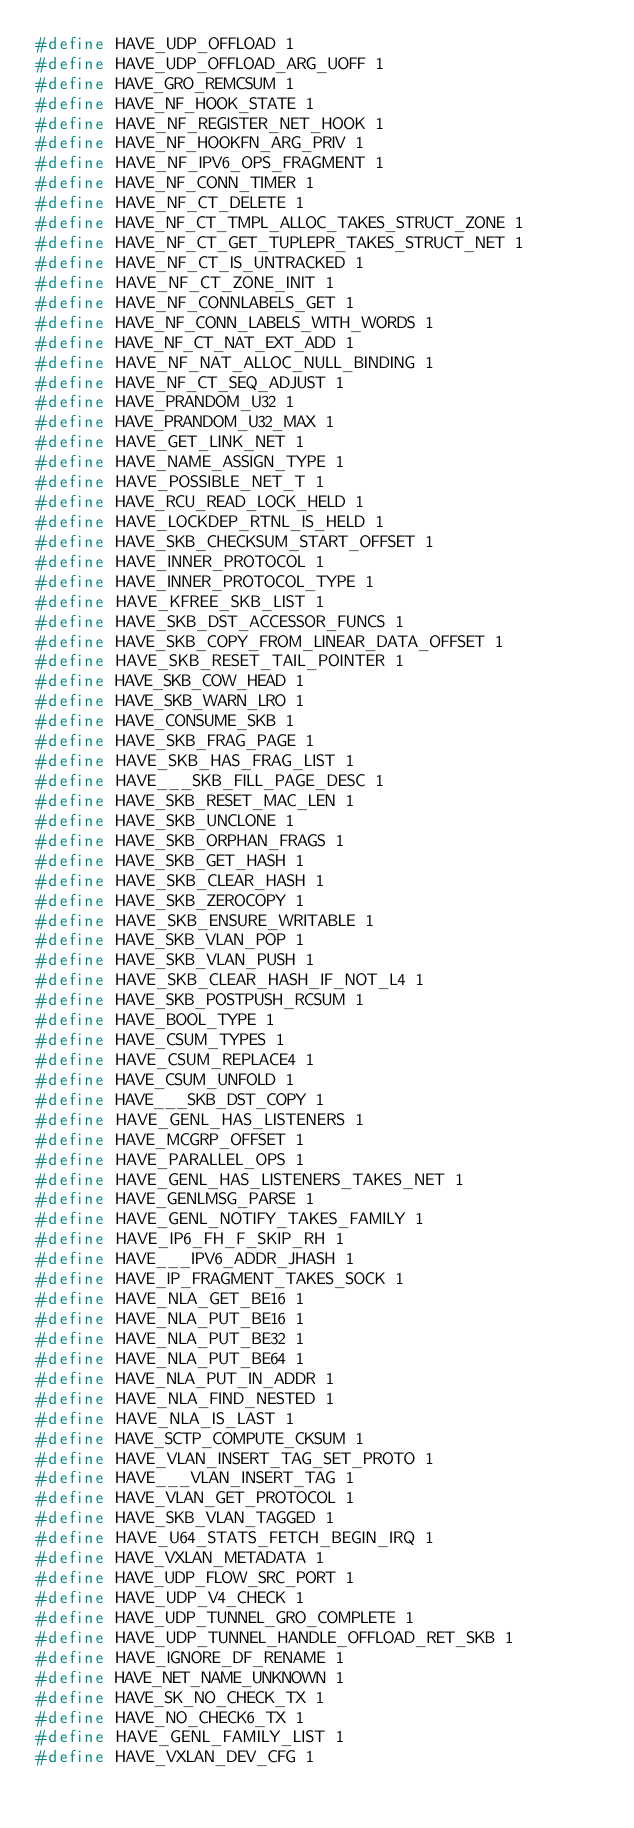<code> <loc_0><loc_0><loc_500><loc_500><_C_>#define HAVE_UDP_OFFLOAD 1
#define HAVE_UDP_OFFLOAD_ARG_UOFF 1
#define HAVE_GRO_REMCSUM 1
#define HAVE_NF_HOOK_STATE 1
#define HAVE_NF_REGISTER_NET_HOOK 1
#define HAVE_NF_HOOKFN_ARG_PRIV 1
#define HAVE_NF_IPV6_OPS_FRAGMENT 1
#define HAVE_NF_CONN_TIMER 1
#define HAVE_NF_CT_DELETE 1
#define HAVE_NF_CT_TMPL_ALLOC_TAKES_STRUCT_ZONE 1
#define HAVE_NF_CT_GET_TUPLEPR_TAKES_STRUCT_NET 1
#define HAVE_NF_CT_IS_UNTRACKED 1
#define HAVE_NF_CT_ZONE_INIT 1
#define HAVE_NF_CONNLABELS_GET 1
#define HAVE_NF_CONN_LABELS_WITH_WORDS 1
#define HAVE_NF_CT_NAT_EXT_ADD 1
#define HAVE_NF_NAT_ALLOC_NULL_BINDING 1
#define HAVE_NF_CT_SEQ_ADJUST 1
#define HAVE_PRANDOM_U32 1
#define HAVE_PRANDOM_U32_MAX 1
#define HAVE_GET_LINK_NET 1
#define HAVE_NAME_ASSIGN_TYPE 1
#define HAVE_POSSIBLE_NET_T 1
#define HAVE_RCU_READ_LOCK_HELD 1
#define HAVE_LOCKDEP_RTNL_IS_HELD 1
#define HAVE_SKB_CHECKSUM_START_OFFSET 1
#define HAVE_INNER_PROTOCOL 1
#define HAVE_INNER_PROTOCOL_TYPE 1
#define HAVE_KFREE_SKB_LIST 1
#define HAVE_SKB_DST_ACCESSOR_FUNCS 1
#define HAVE_SKB_COPY_FROM_LINEAR_DATA_OFFSET 1
#define HAVE_SKB_RESET_TAIL_POINTER 1
#define HAVE_SKB_COW_HEAD 1
#define HAVE_SKB_WARN_LRO 1
#define HAVE_CONSUME_SKB 1
#define HAVE_SKB_FRAG_PAGE 1
#define HAVE_SKB_HAS_FRAG_LIST 1
#define HAVE___SKB_FILL_PAGE_DESC 1
#define HAVE_SKB_RESET_MAC_LEN 1
#define HAVE_SKB_UNCLONE 1
#define HAVE_SKB_ORPHAN_FRAGS 1
#define HAVE_SKB_GET_HASH 1
#define HAVE_SKB_CLEAR_HASH 1
#define HAVE_SKB_ZEROCOPY 1
#define HAVE_SKB_ENSURE_WRITABLE 1
#define HAVE_SKB_VLAN_POP 1
#define HAVE_SKB_VLAN_PUSH 1
#define HAVE_SKB_CLEAR_HASH_IF_NOT_L4 1
#define HAVE_SKB_POSTPUSH_RCSUM 1
#define HAVE_BOOL_TYPE 1
#define HAVE_CSUM_TYPES 1
#define HAVE_CSUM_REPLACE4 1
#define HAVE_CSUM_UNFOLD 1
#define HAVE___SKB_DST_COPY 1
#define HAVE_GENL_HAS_LISTENERS 1
#define HAVE_MCGRP_OFFSET 1
#define HAVE_PARALLEL_OPS 1
#define HAVE_GENL_HAS_LISTENERS_TAKES_NET 1
#define HAVE_GENLMSG_PARSE 1
#define HAVE_GENL_NOTIFY_TAKES_FAMILY 1
#define HAVE_IP6_FH_F_SKIP_RH 1
#define HAVE___IPV6_ADDR_JHASH 1
#define HAVE_IP_FRAGMENT_TAKES_SOCK 1
#define HAVE_NLA_GET_BE16 1
#define HAVE_NLA_PUT_BE16 1
#define HAVE_NLA_PUT_BE32 1
#define HAVE_NLA_PUT_BE64 1
#define HAVE_NLA_PUT_IN_ADDR 1
#define HAVE_NLA_FIND_NESTED 1
#define HAVE_NLA_IS_LAST 1
#define HAVE_SCTP_COMPUTE_CKSUM 1
#define HAVE_VLAN_INSERT_TAG_SET_PROTO 1
#define HAVE___VLAN_INSERT_TAG 1
#define HAVE_VLAN_GET_PROTOCOL 1
#define HAVE_SKB_VLAN_TAGGED 1
#define HAVE_U64_STATS_FETCH_BEGIN_IRQ 1
#define HAVE_VXLAN_METADATA 1
#define HAVE_UDP_FLOW_SRC_PORT 1
#define HAVE_UDP_V4_CHECK 1
#define HAVE_UDP_TUNNEL_GRO_COMPLETE 1
#define HAVE_UDP_TUNNEL_HANDLE_OFFLOAD_RET_SKB 1
#define HAVE_IGNORE_DF_RENAME 1
#define HAVE_NET_NAME_UNKNOWN 1
#define HAVE_SK_NO_CHECK_TX 1
#define HAVE_NO_CHECK6_TX 1
#define HAVE_GENL_FAMILY_LIST 1
#define HAVE_VXLAN_DEV_CFG 1
</code> 